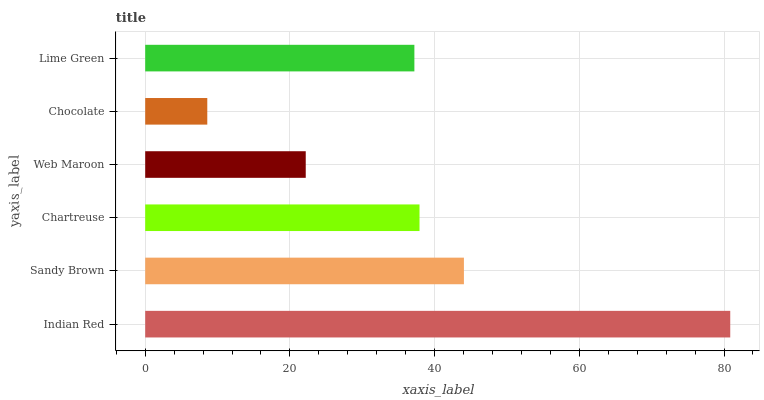Is Chocolate the minimum?
Answer yes or no. Yes. Is Indian Red the maximum?
Answer yes or no. Yes. Is Sandy Brown the minimum?
Answer yes or no. No. Is Sandy Brown the maximum?
Answer yes or no. No. Is Indian Red greater than Sandy Brown?
Answer yes or no. Yes. Is Sandy Brown less than Indian Red?
Answer yes or no. Yes. Is Sandy Brown greater than Indian Red?
Answer yes or no. No. Is Indian Red less than Sandy Brown?
Answer yes or no. No. Is Chartreuse the high median?
Answer yes or no. Yes. Is Lime Green the low median?
Answer yes or no. Yes. Is Web Maroon the high median?
Answer yes or no. No. Is Indian Red the low median?
Answer yes or no. No. 